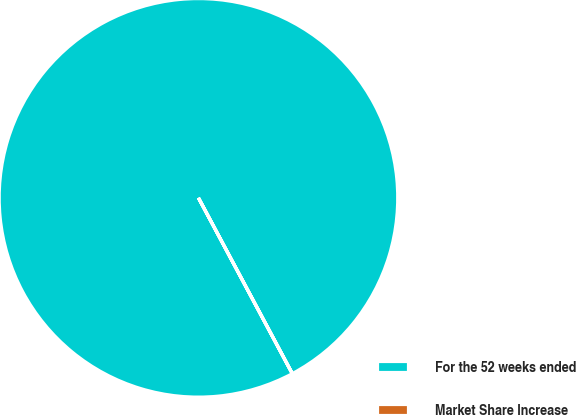<chart> <loc_0><loc_0><loc_500><loc_500><pie_chart><fcel>For the 52 weeks ended<fcel>Market Share Increase<nl><fcel>99.99%<fcel>0.01%<nl></chart> 